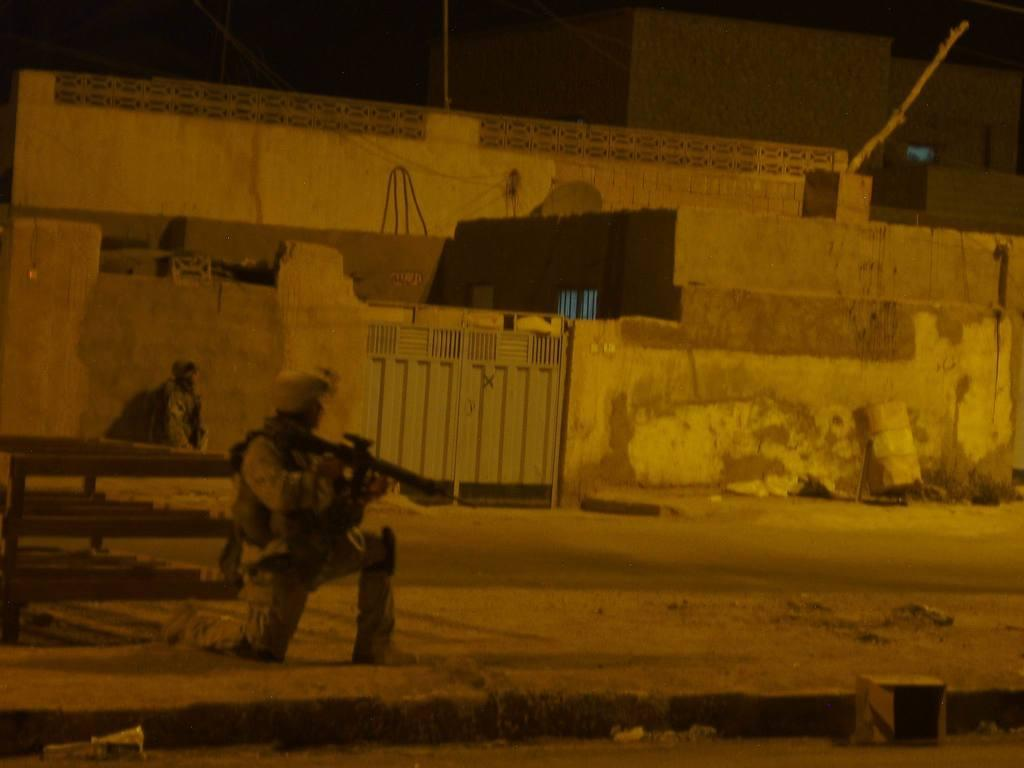How many people are present in the image? There are two persons in the image. What can be seen in the background of the image? There is a gate and a building in the image. What type of cherry is being used as a decoration on the gate in the image? There is no cherry present in the image, and the gate does not appear to have any decorations. 